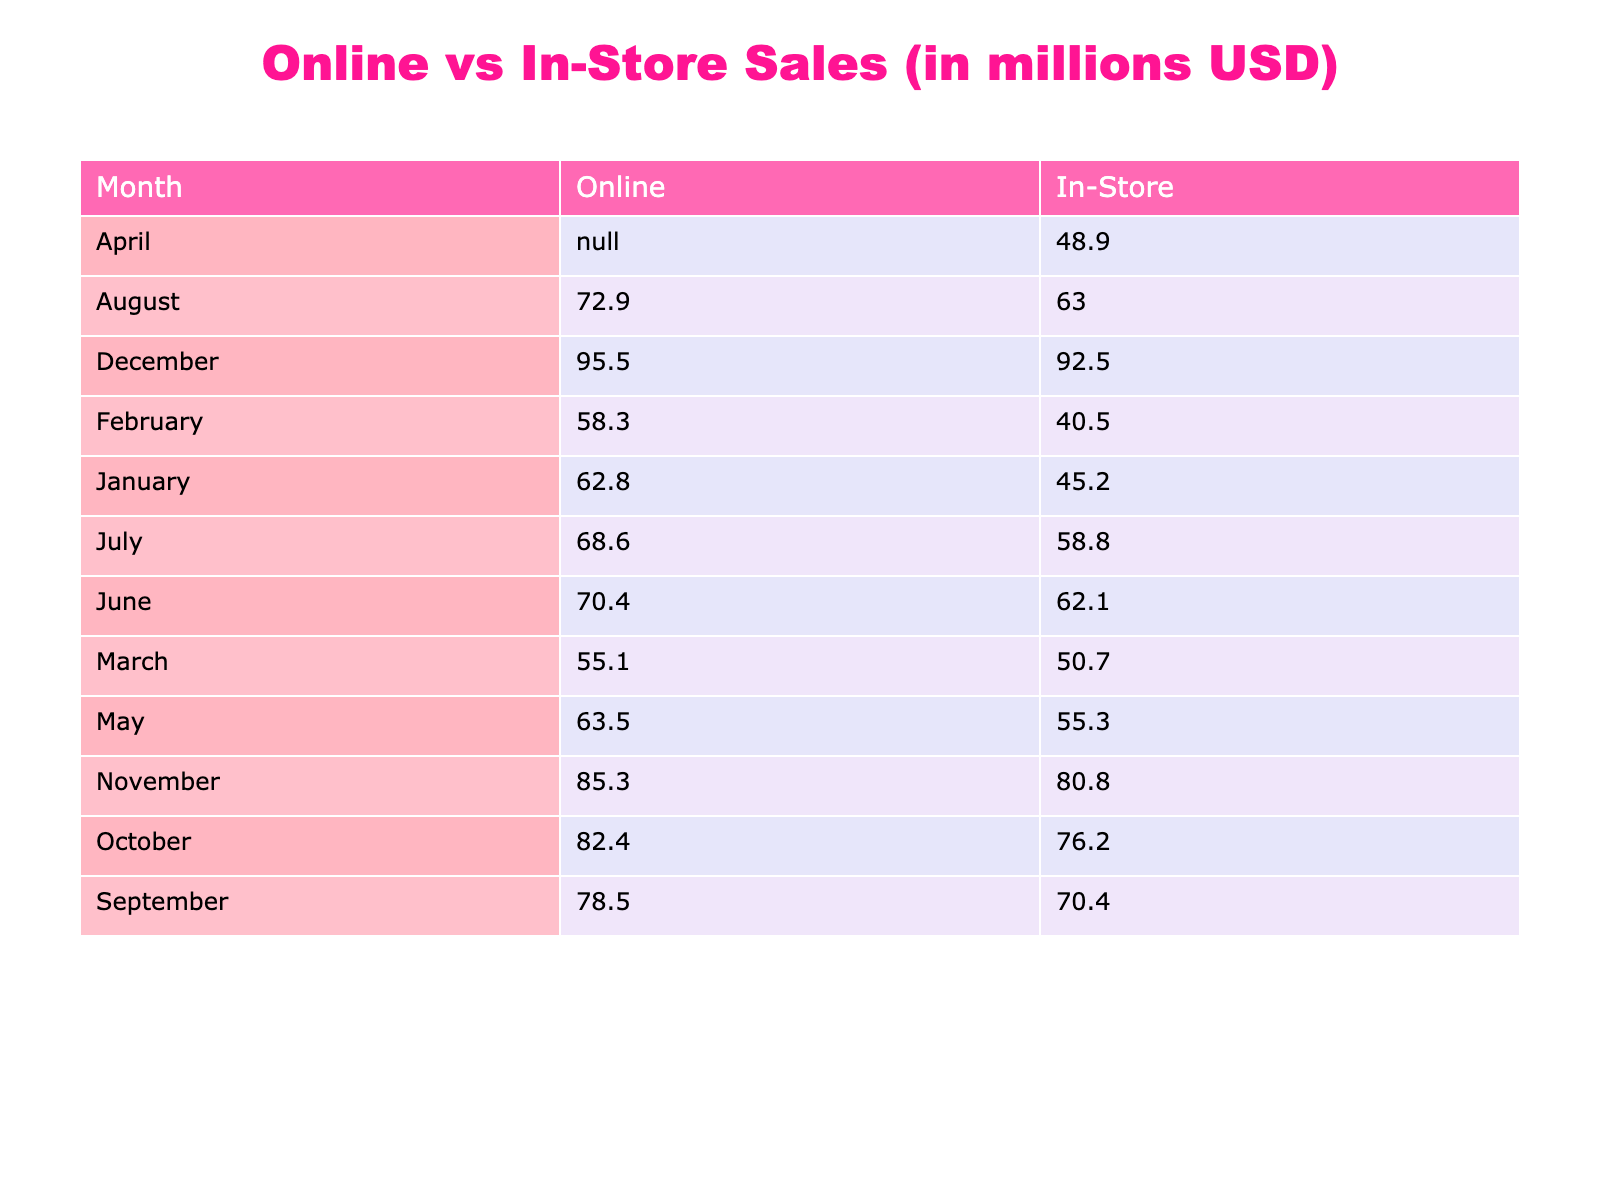What were the online sales for December? The table shows the online sales for December as 92.5 million USD.
Answer: 92.5 million USD Which month had the highest in-store sales? The highest in-store sales are in December, which totaled 95.5 million USD.
Answer: December What is the total sales difference between online and in-store channels in October? In October, online sales are 76.2 million USD, and in-store sales are 82.4 million USD. The difference is 82.4 - 76.2 = 6.2 million USD.
Answer: 6.2 million USD Was the average transaction value higher for online sales or in-store sales in June? The average transaction value for online sales in June is 400 USD, while for in-store sales, it is 550 USD. Since 550 USD is higher than 400 USD, the statement is true.
Answer: Yes If you combine the online sales from January and February, how much is that? The online sales for January are 45.2 million USD and for February are 40.5 million USD. Combining these gives 45.2 + 40.5 = 85.7 million USD.
Answer: 85.7 million USD What brand had the highest sales in March? According to the table, the top-selling brand in March for in-store sales is Dior, with online sales attributed to Versace, which does not surpass in-store sales. However, there is no specific sales value for each brand. Thus the highest selling brand information is ambiguous.
Answer: Ambiguous What was the total number of transactions for online sales in 2022? The total number of transactions can be calculated by summing the Number of Transactions column for online sales: 129 + 126 + 135 + 136 + 143 + 155 + 151 + 154 + 167 + 177 + 184 + 205 = 1,741 transactions.
Answer: 1,741 transactions Which channel had a higher average transaction value in August? The average transaction value for online in August is 410 USD, while for in-store it's 530 USD. Since 530 USD is greater than 410 USD, it's determined that in-store had a higher average.
Answer: In-store What was the cumulative online sales for the first half of the year (January to June)? The online sales for the first six months are: January (45.2) + February (40.5) + March (50.7) + April (48.9) + May (55.3) + June (62.1). The total is 302.7 million USD.
Answer: 302.7 million USD 